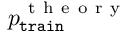<formula> <loc_0><loc_0><loc_500><loc_500>p _ { t r a i n } ^ { t h e o r y }</formula> 